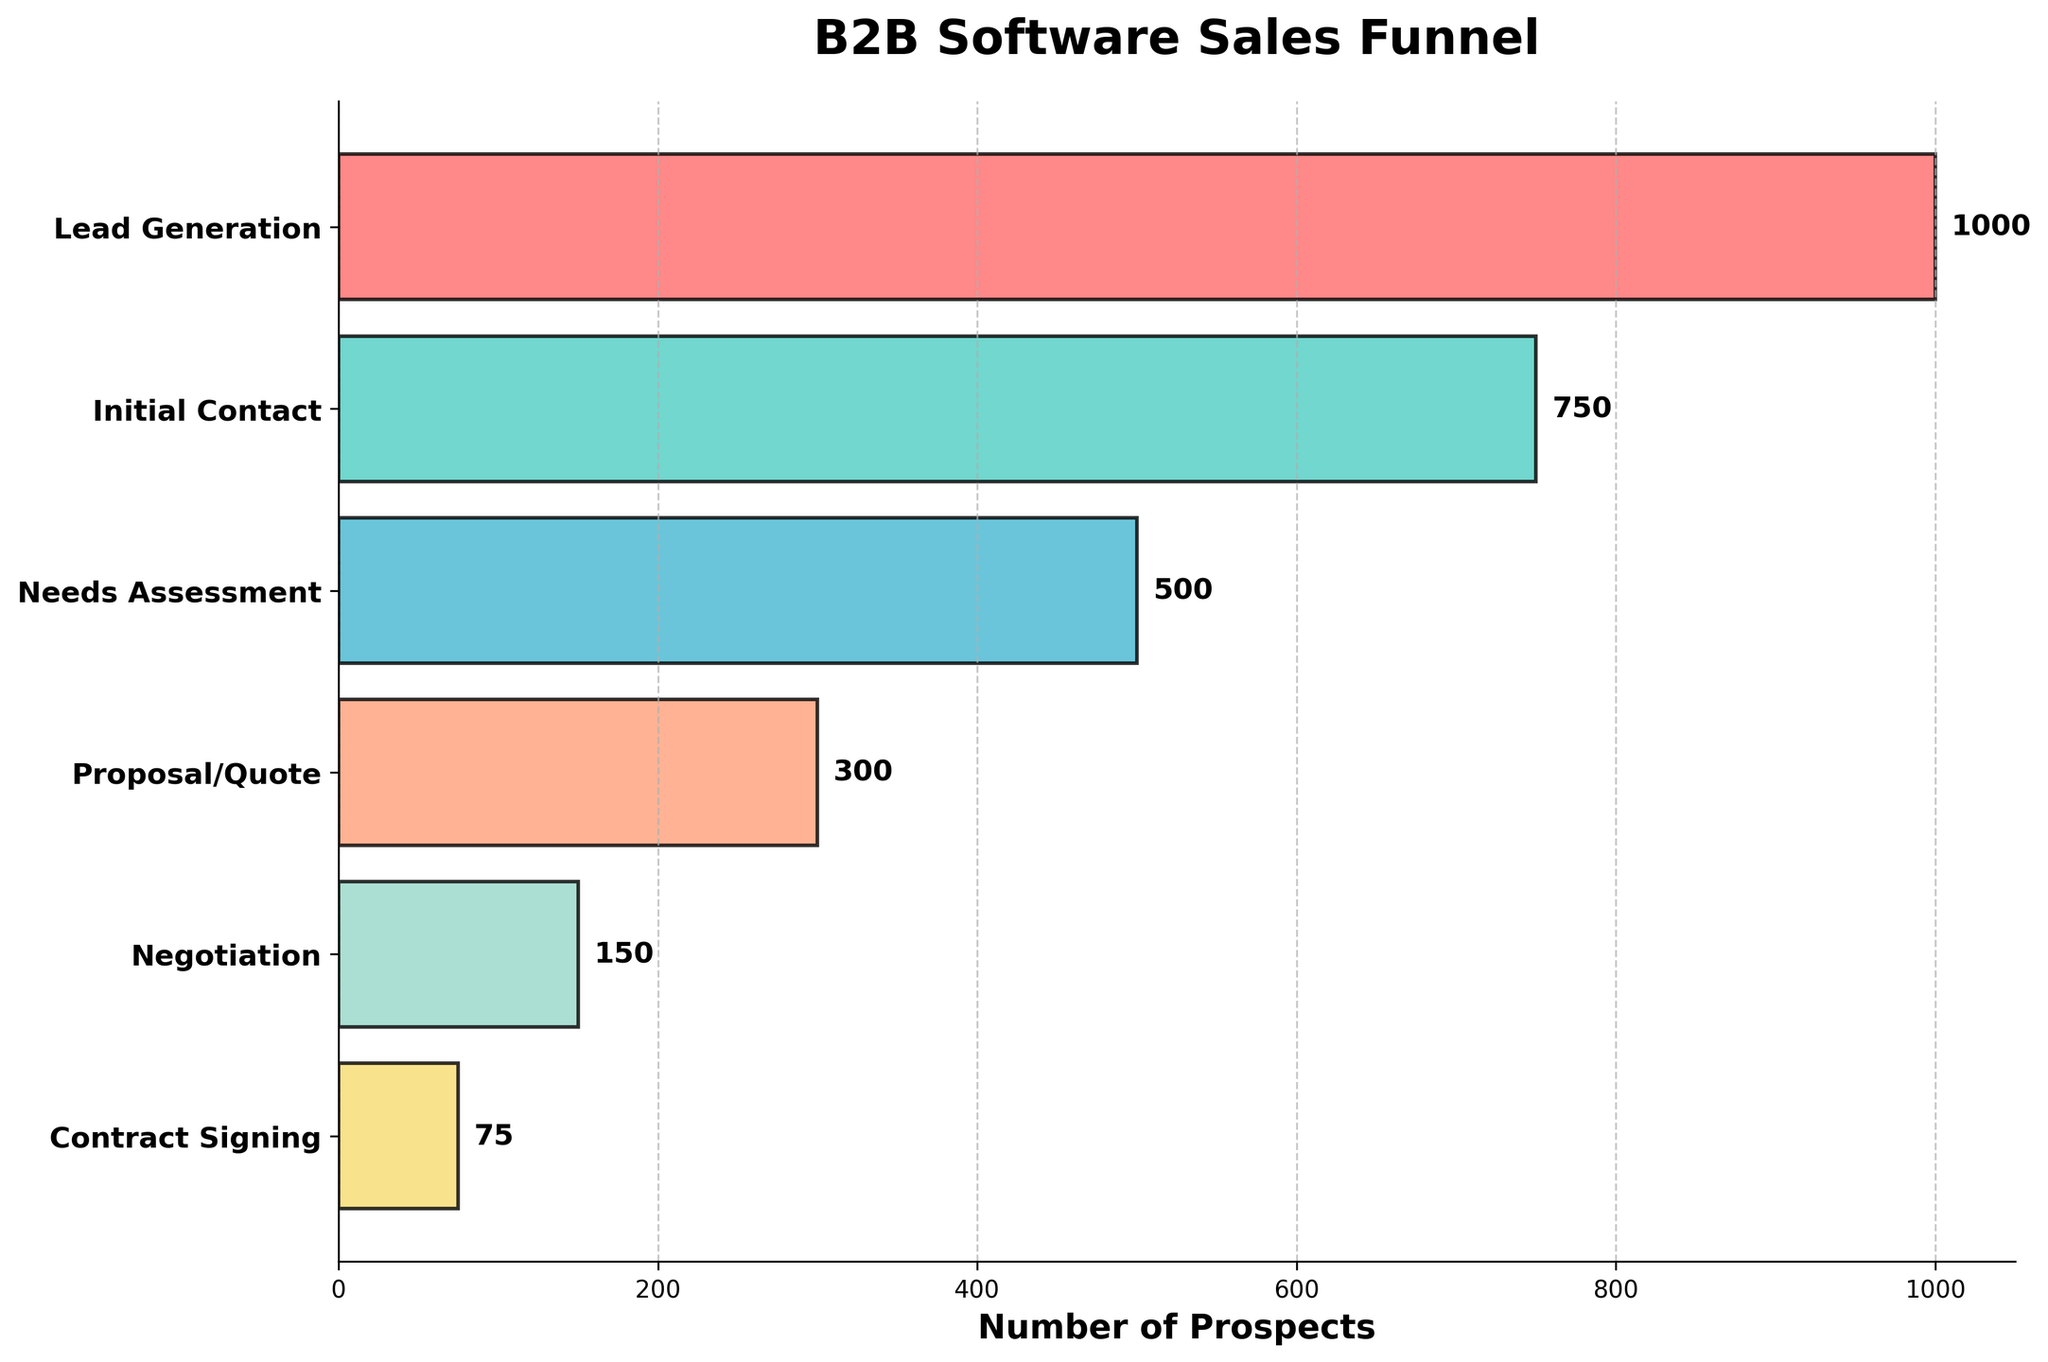What is the title of the figure? The title is displayed at the top of the figure in bold font, making it easy to identify.
Answer: B2B Software Sales Funnel Which stage has the highest number of prospects? The height of the bar representing the number of prospects signifies the quantity at each stage. The first stage, Lead Generation, has the longest bar.
Answer: Lead Generation How many prospects reach the Proposal/Quote stage? The number of prospects for each stage is labeled at the end of each bar, and for the Proposal/Quote stage, it is marked as 300.
Answer: 300 What is the difference in the number of prospects between the Initial Contact and Contract Signing stages? To find the difference, subtract the number of prospects in the Contract Signing stage (75) from the Initial Contact stage (750). 750 - 75 = 675.
Answer: 675 Which stage sees the biggest drop in the number of prospects? By comparing the differences between consecutive stages, the drop from Initial Contact (750) to Needs Assessment (500) is the largest, being 250 prospects.
Answer: Initial Contact to Needs Assessment How many prospects are lost from the Proposal/Quote to Contract Signing stages? The number of prospects lost can be calculated by subtracting the final number (75) from the initial number (300). 300 - 75 = 225.
Answer: 225 List all the colors used in the figure. The figure uses a custom color palette which includes six different colors, one for each stage of the funnel.
Answer: Red, Teal, Light Blue, Salmon, Light Green, Yellow What is the average number of prospects across all stages? Sum the number of prospects at all stages (1000 + 750 + 500 + 300 + 150 + 75) and divide by the number of stages (6). The sum is 2775, so 2775 / 6 = 462.5.
Answer: 462.5 How does the number of prospects in the Negotiation stage compare to the one in the Needs Assessment stage? The negotiation stage has 150 prospects while the Needs Assessment stage has 500 prospects. 150 is less than 500.
Answer: Less What percentage of initial leads go on to sign the contract? Divide the number of prospects at the Contract Signing stage by the number of leads in Lead Generation, then multiply by 100. (75 / 1000) * 100 = 7.5%.
Answer: 7.5% 